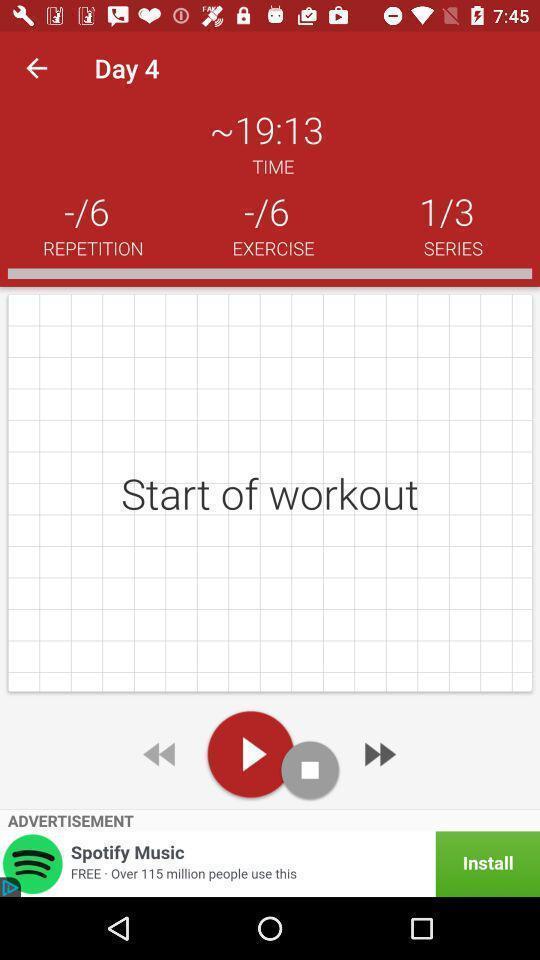What details can you identify in this image? Window displaying a workout app. 